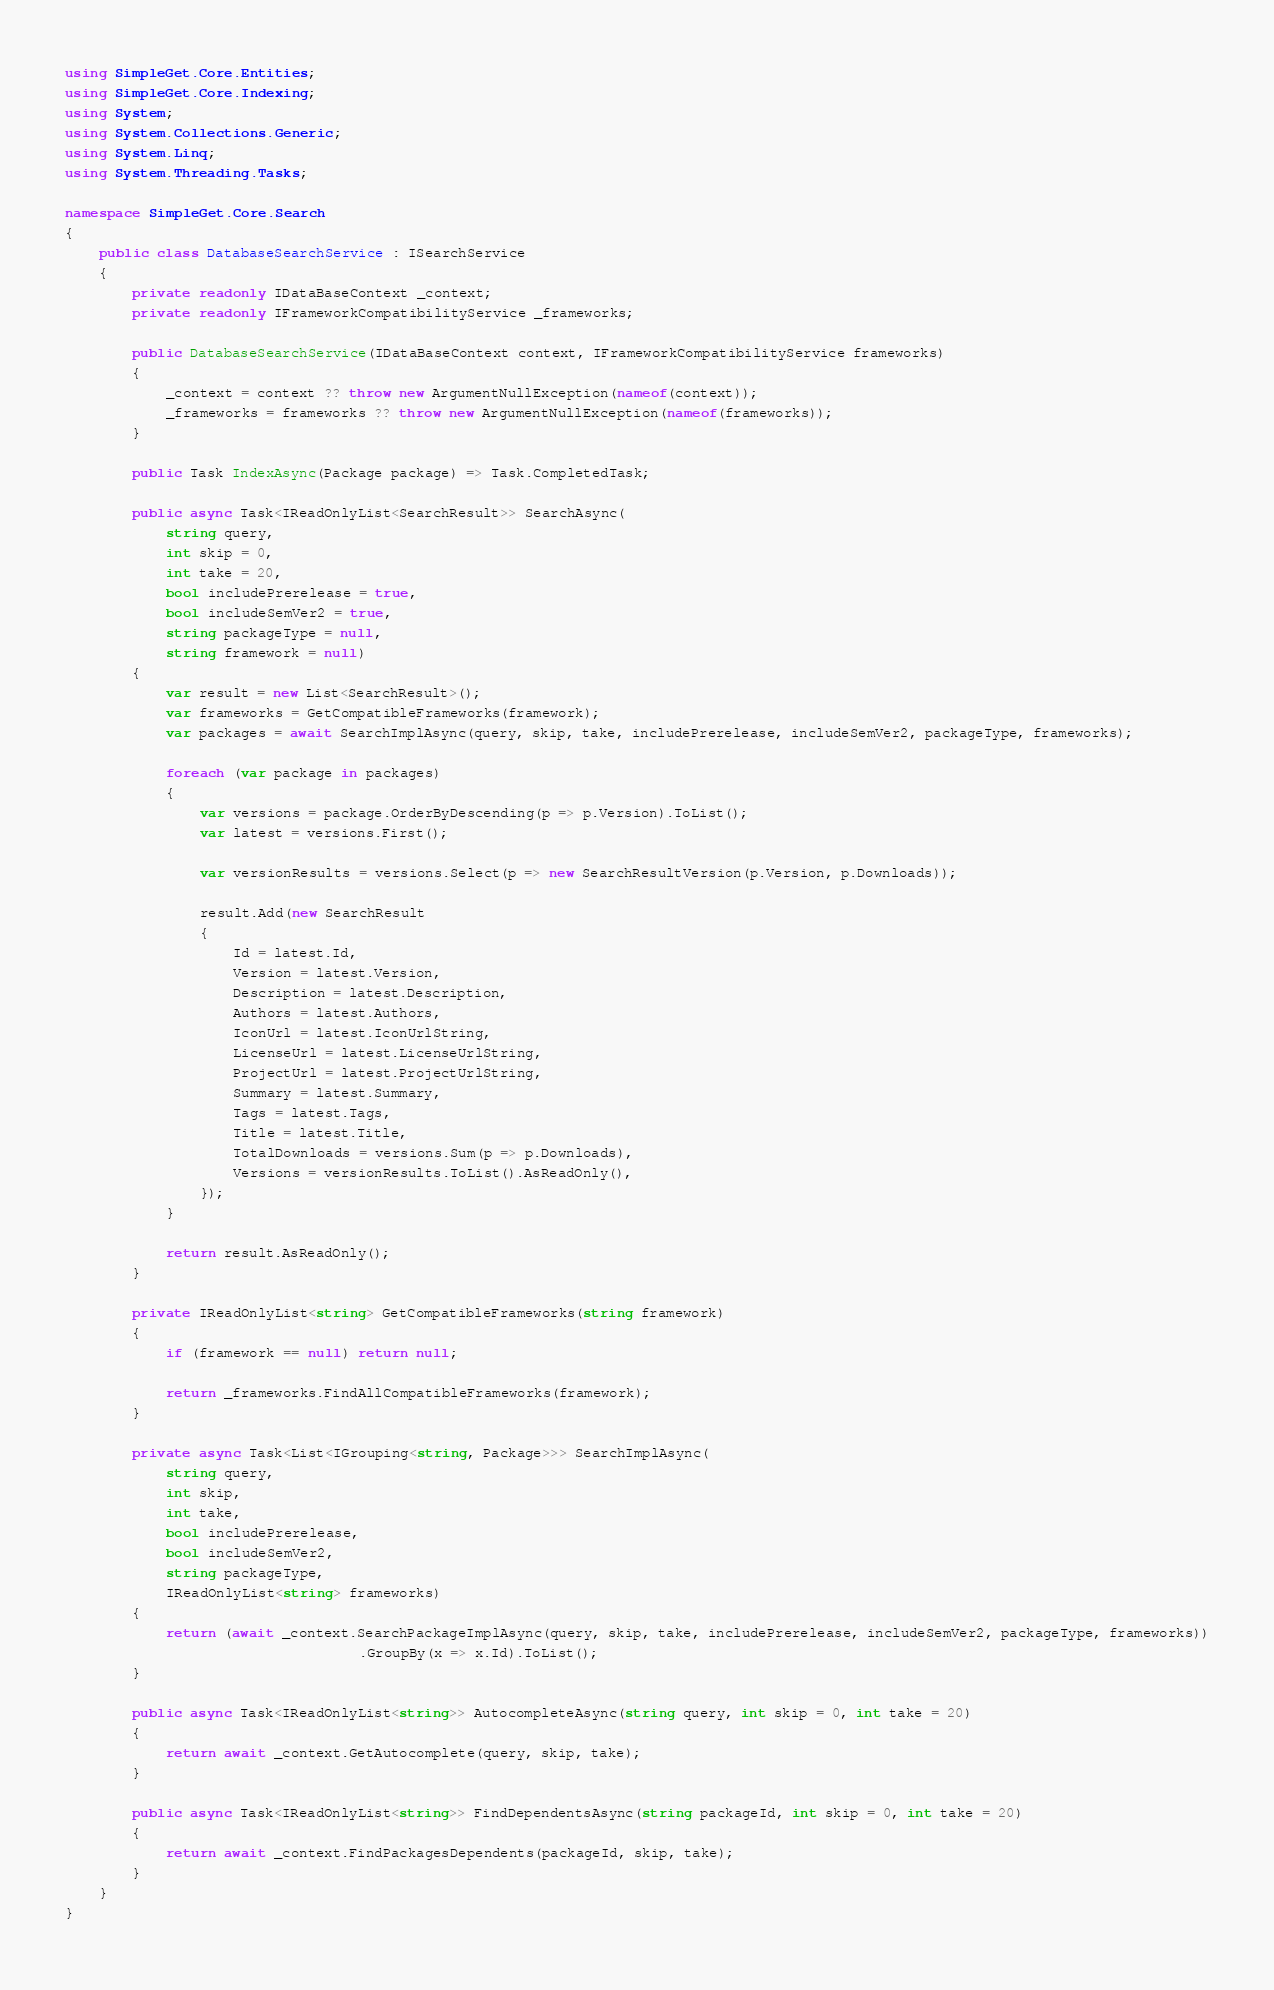Convert code to text. <code><loc_0><loc_0><loc_500><loc_500><_C#_>using SimpleGet.Core.Entities;
using SimpleGet.Core.Indexing;
using System;
using System.Collections.Generic;
using System.Linq;
using System.Threading.Tasks;

namespace SimpleGet.Core.Search
{
    public class DatabaseSearchService : ISearchService
    {
        private readonly IDataBaseContext _context;
        private readonly IFrameworkCompatibilityService _frameworks;

        public DatabaseSearchService(IDataBaseContext context, IFrameworkCompatibilityService frameworks)
        {
            _context = context ?? throw new ArgumentNullException(nameof(context));
            _frameworks = frameworks ?? throw new ArgumentNullException(nameof(frameworks));
        }

        public Task IndexAsync(Package package) => Task.CompletedTask;

        public async Task<IReadOnlyList<SearchResult>> SearchAsync(
            string query,
            int skip = 0,
            int take = 20,
            bool includePrerelease = true,
            bool includeSemVer2 = true,
            string packageType = null,
            string framework = null)
        {
            var result = new List<SearchResult>();
            var frameworks = GetCompatibleFrameworks(framework);
            var packages = await SearchImplAsync(query, skip, take, includePrerelease, includeSemVer2, packageType, frameworks);

            foreach (var package in packages)
            {
                var versions = package.OrderByDescending(p => p.Version).ToList();
                var latest = versions.First();

                var versionResults = versions.Select(p => new SearchResultVersion(p.Version, p.Downloads));

                result.Add(new SearchResult
                {
                    Id = latest.Id,
                    Version = latest.Version,
                    Description = latest.Description,
                    Authors = latest.Authors,
                    IconUrl = latest.IconUrlString,
                    LicenseUrl = latest.LicenseUrlString,
                    ProjectUrl = latest.ProjectUrlString,
                    Summary = latest.Summary,
                    Tags = latest.Tags,
                    Title = latest.Title,
                    TotalDownloads = versions.Sum(p => p.Downloads),
                    Versions = versionResults.ToList().AsReadOnly(),
                });
            }

            return result.AsReadOnly();
        }

        private IReadOnlyList<string> GetCompatibleFrameworks(string framework)
        {
            if (framework == null) return null;

            return _frameworks.FindAllCompatibleFrameworks(framework);
        }

        private async Task<List<IGrouping<string, Package>>> SearchImplAsync(
            string query,
            int skip,
            int take,
            bool includePrerelease,
            bool includeSemVer2,
            string packageType,
            IReadOnlyList<string> frameworks)
        {
            return (await _context.SearchPackageImplAsync(query, skip, take, includePrerelease, includeSemVer2, packageType, frameworks))
                                   .GroupBy(x => x.Id).ToList();
        }

        public async Task<IReadOnlyList<string>> AutocompleteAsync(string query, int skip = 0, int take = 20)
        {
            return await _context.GetAutocomplete(query, skip, take);
        }

        public async Task<IReadOnlyList<string>> FindDependentsAsync(string packageId, int skip = 0, int take = 20)
        {
            return await _context.FindPackagesDependents(packageId, skip, take);
        }
    }
}
</code> 